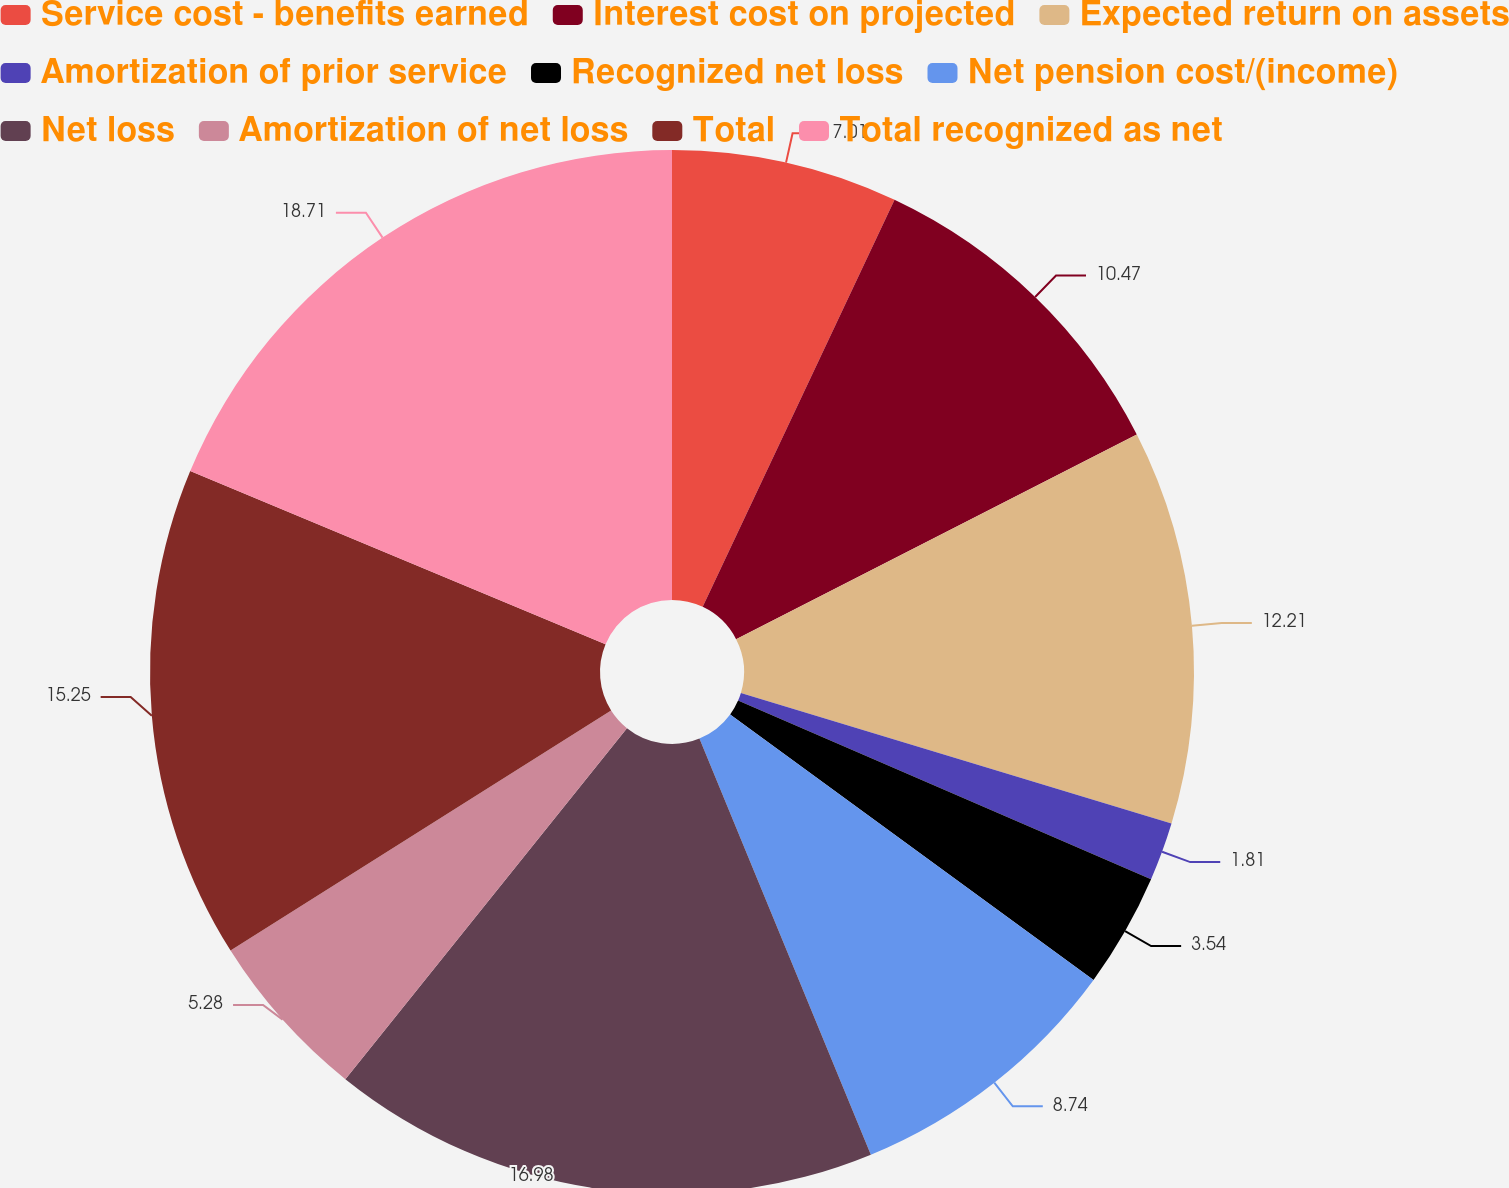Convert chart to OTSL. <chart><loc_0><loc_0><loc_500><loc_500><pie_chart><fcel>Service cost - benefits earned<fcel>Interest cost on projected<fcel>Expected return on assets<fcel>Amortization of prior service<fcel>Recognized net loss<fcel>Net pension cost/(income)<fcel>Net loss<fcel>Amortization of net loss<fcel>Total<fcel>Total recognized as net<nl><fcel>7.01%<fcel>10.47%<fcel>12.21%<fcel>1.81%<fcel>3.54%<fcel>8.74%<fcel>16.98%<fcel>5.28%<fcel>15.25%<fcel>18.71%<nl></chart> 